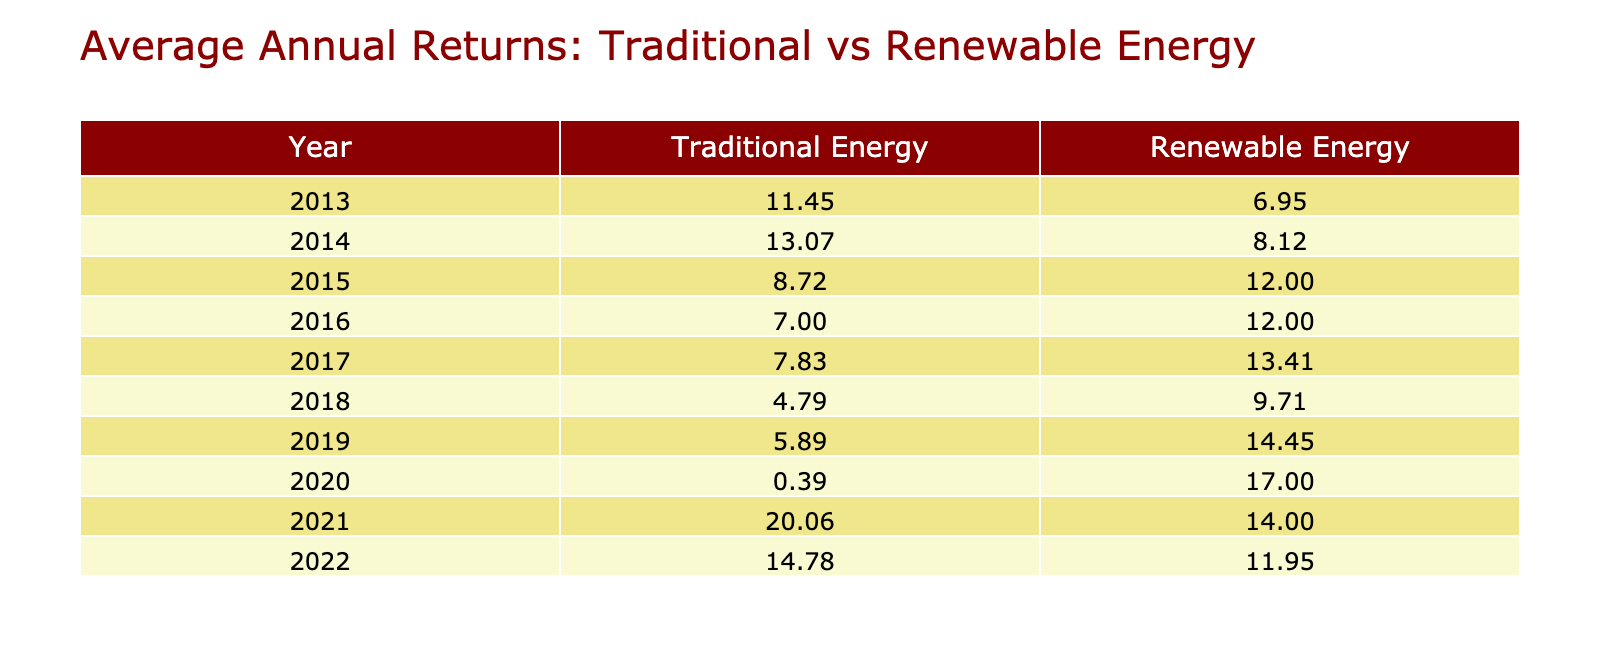What was the average annual return for Renewable Energy in 2013? In 2013, the annual return for NextEra Energy was 8.23%, and for First Solar, it was 5.67%. To find the average, we add these two values: 8.23 + 5.67 = 13.90, and divide by 2, giving us 13.90 / 2 = 6.95.
Answer: 6.95% What was the highest annual return for Traditional Energy stocks over the decade? By observing the table, we can see that in 2021, ExxonMobil had the highest return at 21.45%. Checking all the years, no other Traditional Energy stock reached this value, making it the highest.
Answer: 21.45% Did any Renewable Energy stock have a negative annual return in 2020? In 2020, the table shows that NextEra Energy had a return of 18.23% and First Solar had 15.78%. Both values are positive, indicating no Renewable Energy stock had a negative return that year.
Answer: No What is the average annual return of Traditional Energy stocks from 2019 to 2022? The returns for Traditional Energy from 2019 to 2022 are as follows: 2019: 5.67%, 2020: -1.56%, 2021: 18.67%, and 2022: 13.89%. First, we sum these values: 5.67 + (-1.56) + 18.67 + 13.89 = 36.67. Next, we divide by the number of years (4), leading to an average of 36.67 / 4 = 9.1675.
Answer: 9.17% Which category had a higher average return in 2021, Traditional or Renewable Energy? In 2021, the returns were: Traditional Energy (ExxonMobil: 21.45%, Chevron: 18.67%) and Renewable Energy (NextEra Energy: 14.56%, First Solar: 13.45%). We calculate the average for each: Traditional: (21.45 + 18.67) / 2 = 20.06; Renewable: (14.56 + 13.45) / 2 = 14.005. Comparing 20.06 and 14.005 shows Traditional Energy had the higher average.
Answer: Traditional Energy What was the trend in annual returns for First Solar over the decade? The annual returns for First Solar from 2013 to 2022 are: 5.67%, 6.78%, 11.34%, 10.12%, 12.56%, 8.45%, 13.56%, and 11.56%. To identify the trend, we can observe the changes over the years: it increased from 2013 to 2015, decreased in 2016 and 2018, then increased again from 2019 to 2022, indicating a fluctuating positive trend overall.
Answer: Fluctuating positive trend In which year did Chevron record the lowest annual return? By analyzing the table, we can see that Chevron's returns were: 10.56% (2013), 11.22% (2014), 8.11% (2015), 6.45% (2016), 6.98% (2017), 4.23% (2018), 5.67% (2019), -1.56% (2020), 18.67% (2021), and 13.89% (2022). The lowest annual return was in 2020 at -1.56%.
Answer: 2020 